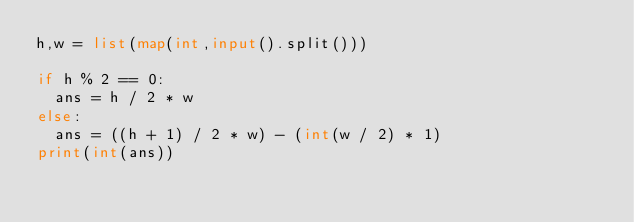Convert code to text. <code><loc_0><loc_0><loc_500><loc_500><_Python_>h,w = list(map(int,input().split()))
 
if h % 2 == 0:
  ans = h / 2 * w
else:
  ans = ((h + 1) / 2 * w) - (int(w / 2) * 1)
print(int(ans))</code> 